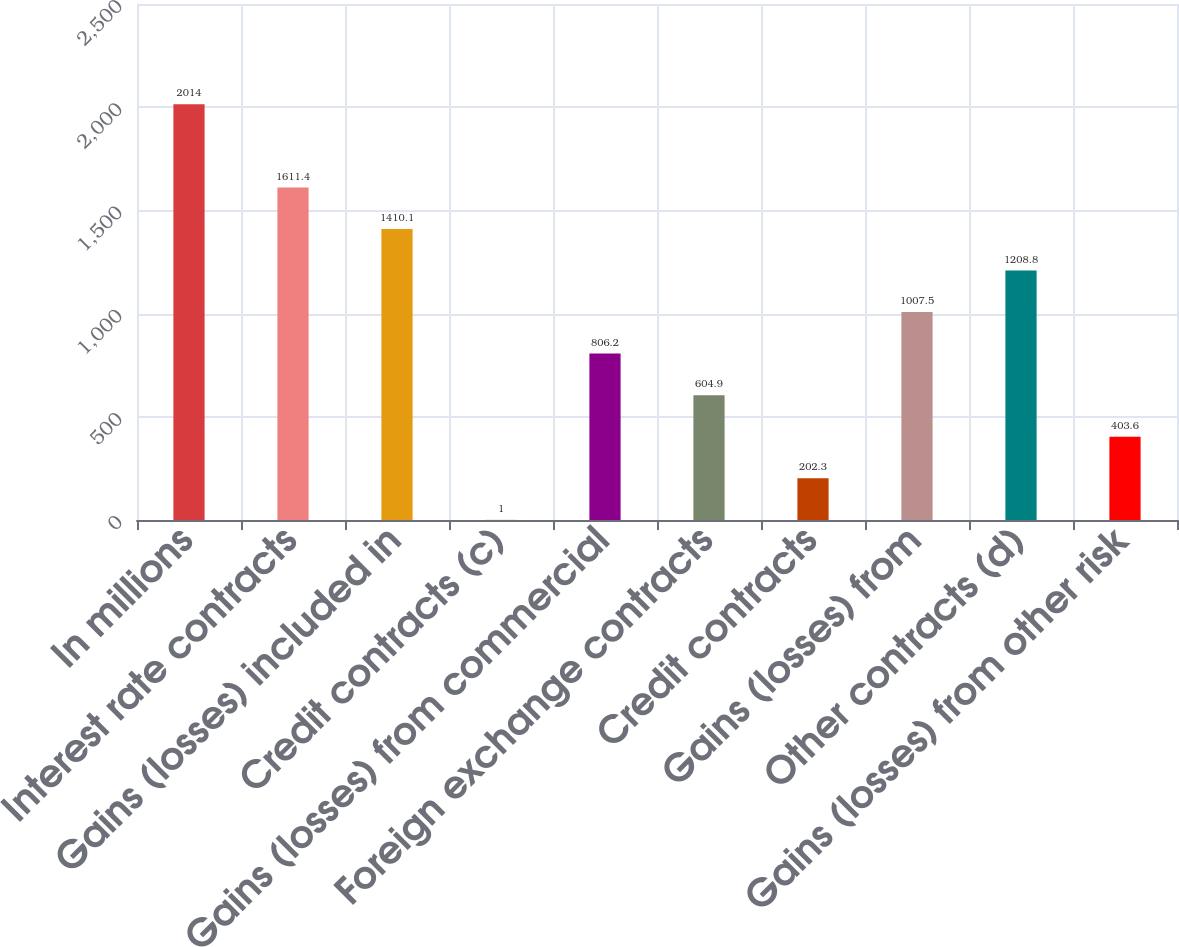Convert chart. <chart><loc_0><loc_0><loc_500><loc_500><bar_chart><fcel>In millions<fcel>Interest rate contracts<fcel>Gains (losses) included in<fcel>Credit contracts (c)<fcel>Gains (losses) from commercial<fcel>Foreign exchange contracts<fcel>Credit contracts<fcel>Gains (losses) from<fcel>Other contracts (d)<fcel>Gains (losses) from other risk<nl><fcel>2014<fcel>1611.4<fcel>1410.1<fcel>1<fcel>806.2<fcel>604.9<fcel>202.3<fcel>1007.5<fcel>1208.8<fcel>403.6<nl></chart> 